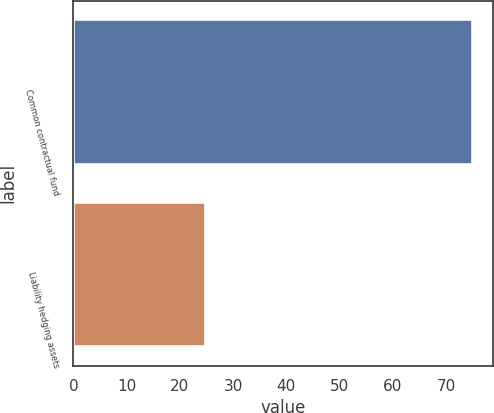Convert chart. <chart><loc_0><loc_0><loc_500><loc_500><bar_chart><fcel>Common contractual fund<fcel>Liability hedging assets<nl><fcel>75<fcel>25<nl></chart> 